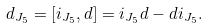<formula> <loc_0><loc_0><loc_500><loc_500>d _ { J _ { 5 } } = [ i _ { J _ { 5 } } , d ] = i _ { J _ { 5 } } d - d i _ { J _ { 5 } } .</formula> 